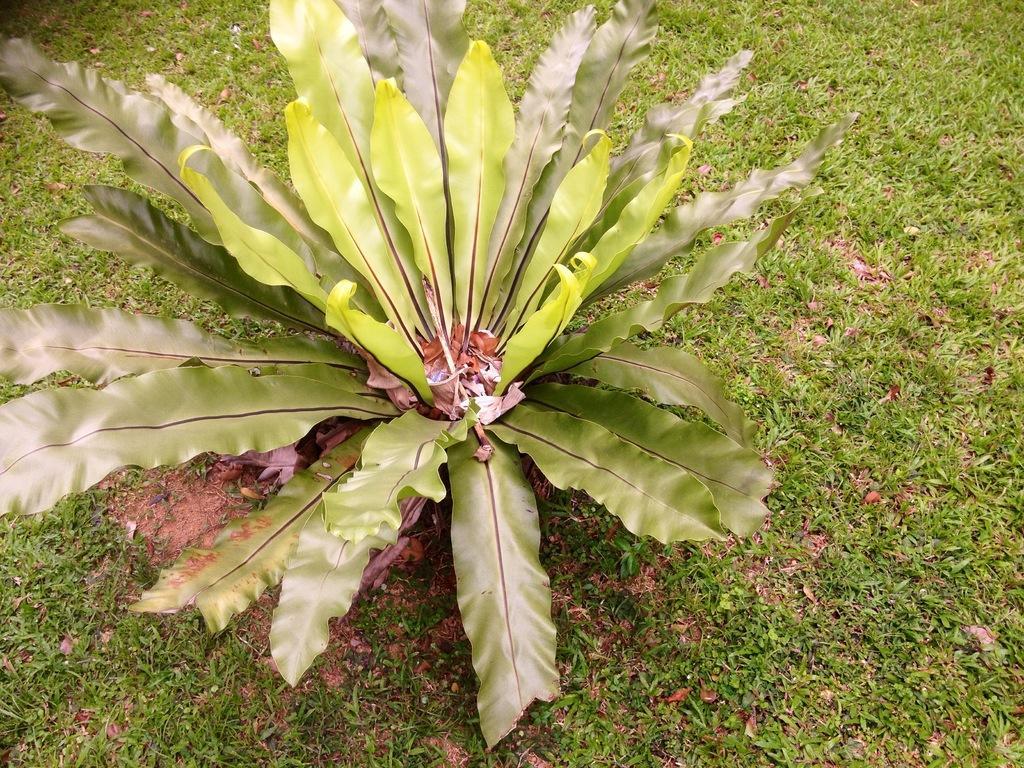How would you summarize this image in a sentence or two? In this picture I can see the grass and a plant in front. 